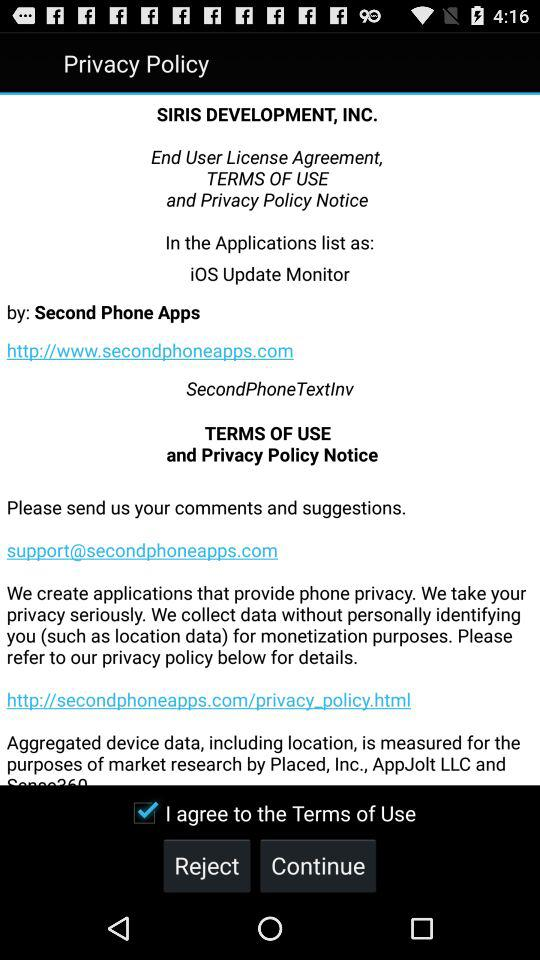How many companies are involved in collecting data?
Answer the question using a single word or phrase. 3 